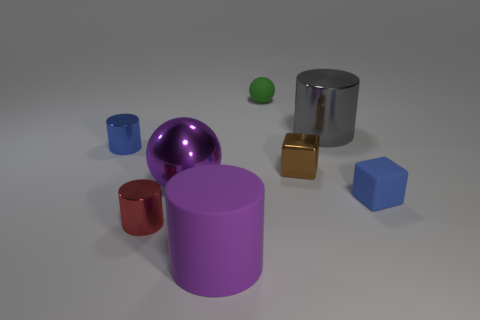Add 1 purple things. How many objects exist? 9 Subtract all blocks. How many objects are left? 6 Subtract all blue metallic things. Subtract all matte cylinders. How many objects are left? 6 Add 3 large rubber objects. How many large rubber objects are left? 4 Add 5 tiny yellow cylinders. How many tiny yellow cylinders exist? 5 Subtract 0 red balls. How many objects are left? 8 